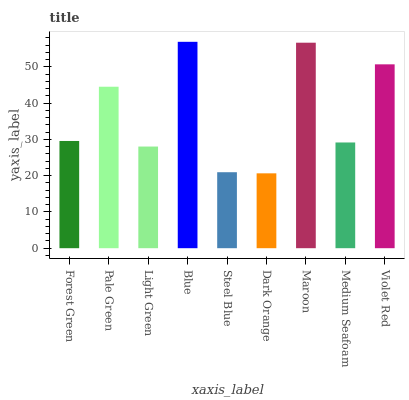Is Dark Orange the minimum?
Answer yes or no. Yes. Is Blue the maximum?
Answer yes or no. Yes. Is Pale Green the minimum?
Answer yes or no. No. Is Pale Green the maximum?
Answer yes or no. No. Is Pale Green greater than Forest Green?
Answer yes or no. Yes. Is Forest Green less than Pale Green?
Answer yes or no. Yes. Is Forest Green greater than Pale Green?
Answer yes or no. No. Is Pale Green less than Forest Green?
Answer yes or no. No. Is Forest Green the high median?
Answer yes or no. Yes. Is Forest Green the low median?
Answer yes or no. Yes. Is Blue the high median?
Answer yes or no. No. Is Blue the low median?
Answer yes or no. No. 